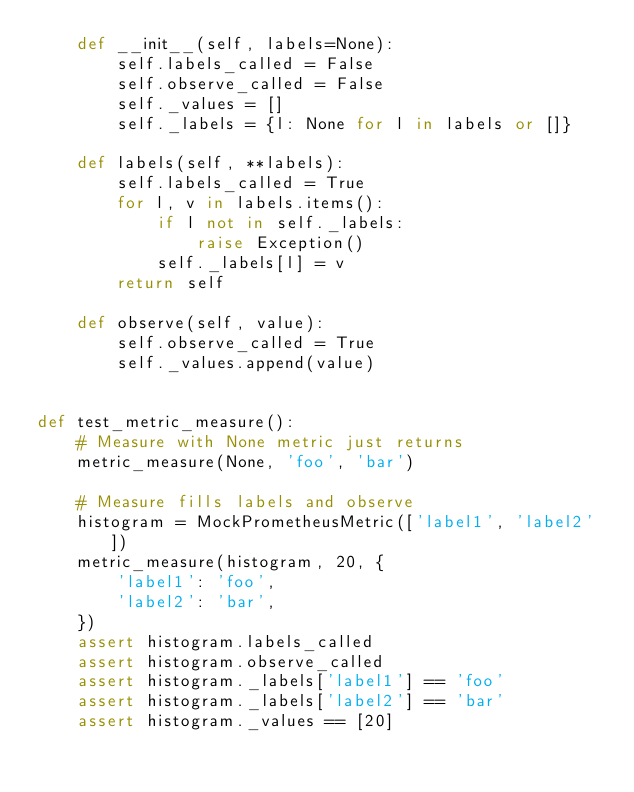<code> <loc_0><loc_0><loc_500><loc_500><_Python_>    def __init__(self, labels=None):
        self.labels_called = False
        self.observe_called = False
        self._values = []
        self._labels = {l: None for l in labels or []}

    def labels(self, **labels):
        self.labels_called = True
        for l, v in labels.items():
            if l not in self._labels:
                raise Exception()
            self._labels[l] = v
        return self

    def observe(self, value):
        self.observe_called = True
        self._values.append(value)


def test_metric_measure():
    # Measure with None metric just returns
    metric_measure(None, 'foo', 'bar')

    # Measure fills labels and observe
    histogram = MockPrometheusMetric(['label1', 'label2'])
    metric_measure(histogram, 20, {
        'label1': 'foo',
        'label2': 'bar',
    })
    assert histogram.labels_called
    assert histogram.observe_called
    assert histogram._labels['label1'] == 'foo'
    assert histogram._labels['label2'] == 'bar'
    assert histogram._values == [20]
</code> 